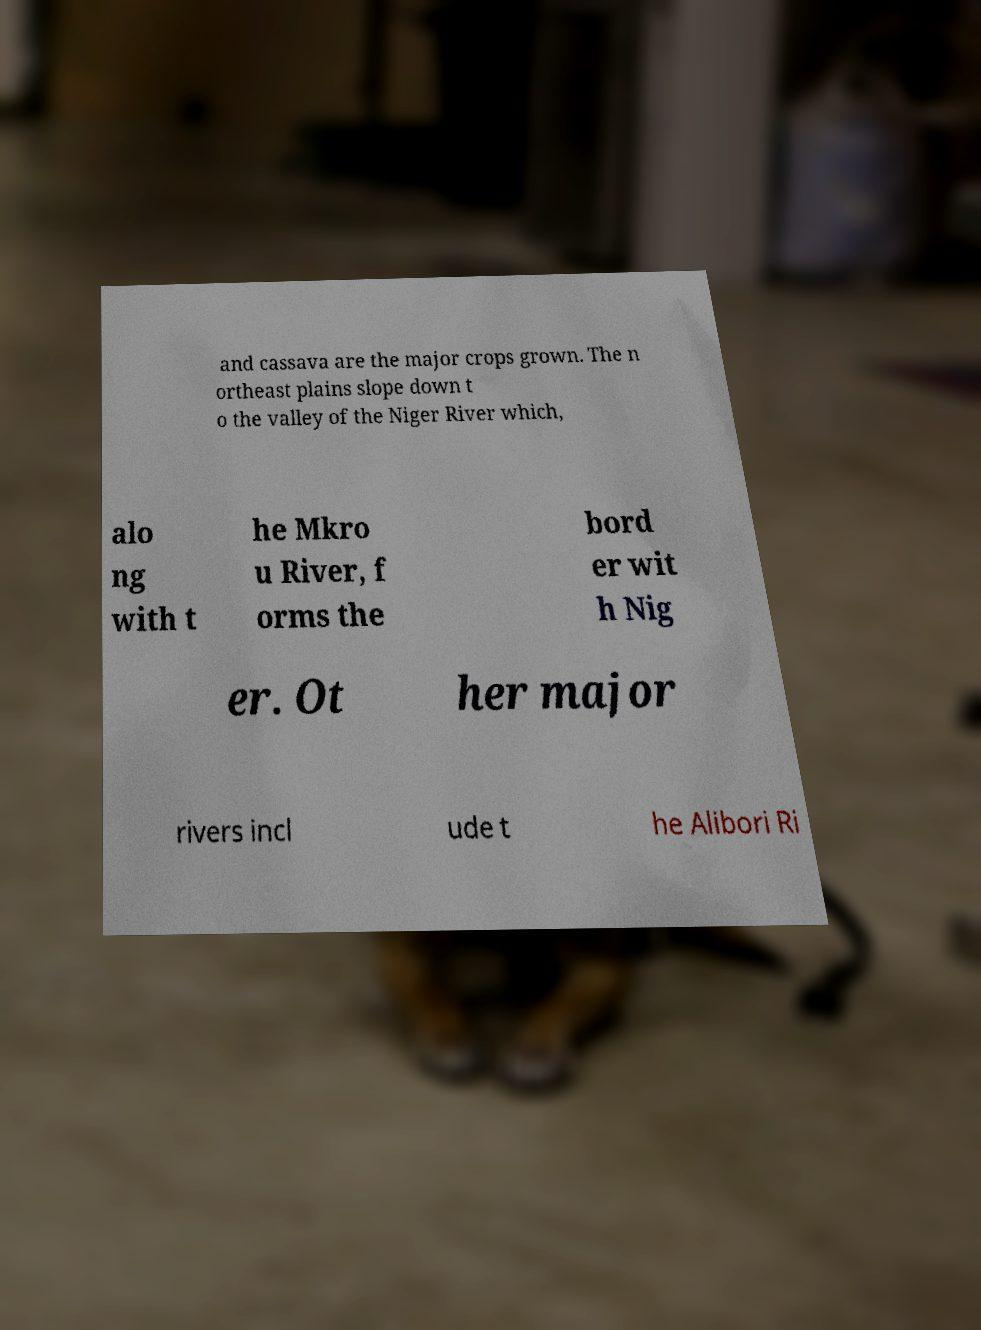Please read and relay the text visible in this image. What does it say? and cassava are the major crops grown. The n ortheast plains slope down t o the valley of the Niger River which, alo ng with t he Mkro u River, f orms the bord er wit h Nig er. Ot her major rivers incl ude t he Alibori Ri 